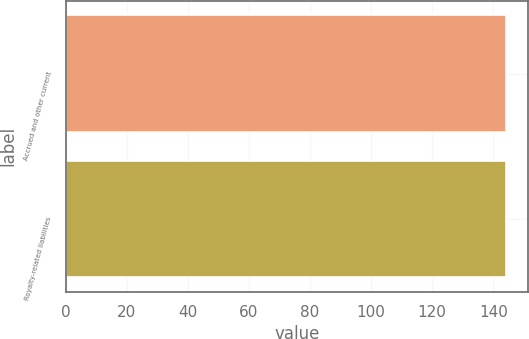<chart> <loc_0><loc_0><loc_500><loc_500><bar_chart><fcel>Accrued and other current<fcel>Royalty-related liabilities<nl><fcel>144<fcel>144.1<nl></chart> 